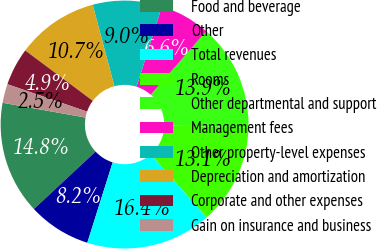<chart> <loc_0><loc_0><loc_500><loc_500><pie_chart><fcel>Food and beverage<fcel>Other<fcel>Total revenues<fcel>Rooms<fcel>Other departmental and support<fcel>Management fees<fcel>Other property-level expenses<fcel>Depreciation and amortization<fcel>Corporate and other expenses<fcel>Gain on insurance and business<nl><fcel>14.75%<fcel>8.2%<fcel>16.39%<fcel>13.11%<fcel>13.93%<fcel>6.56%<fcel>9.02%<fcel>10.66%<fcel>4.92%<fcel>2.46%<nl></chart> 